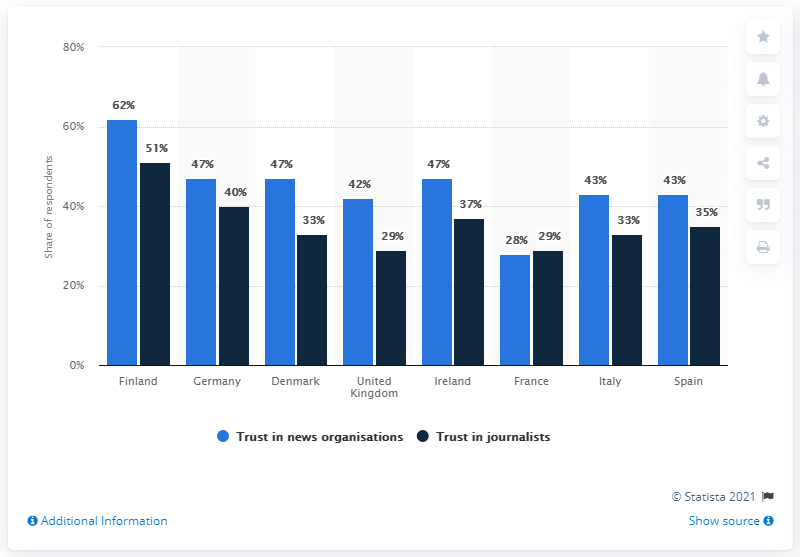Can you show me how the trust levels in journalists are trending in the Scandinavian countries based on the chart? Certainly! Within the Scandinavian countries featured in the chart, Finland exhibits the highest level of trust in journalists at 51%. Denmark follows with 33% of the respondents expressing trust in journalists. This data points to a varying degree of public confidence in journalists across Scandinavian nations, with Finland leading in terms of trust levels. 